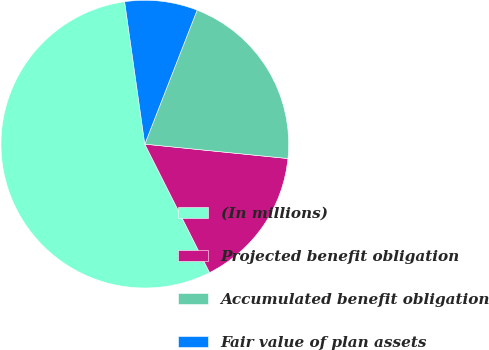Convert chart. <chart><loc_0><loc_0><loc_500><loc_500><pie_chart><fcel>(In millions)<fcel>Projected benefit obligation<fcel>Accumulated benefit obligation<fcel>Fair value of plan assets<nl><fcel>55.19%<fcel>15.97%<fcel>20.67%<fcel>8.16%<nl></chart> 